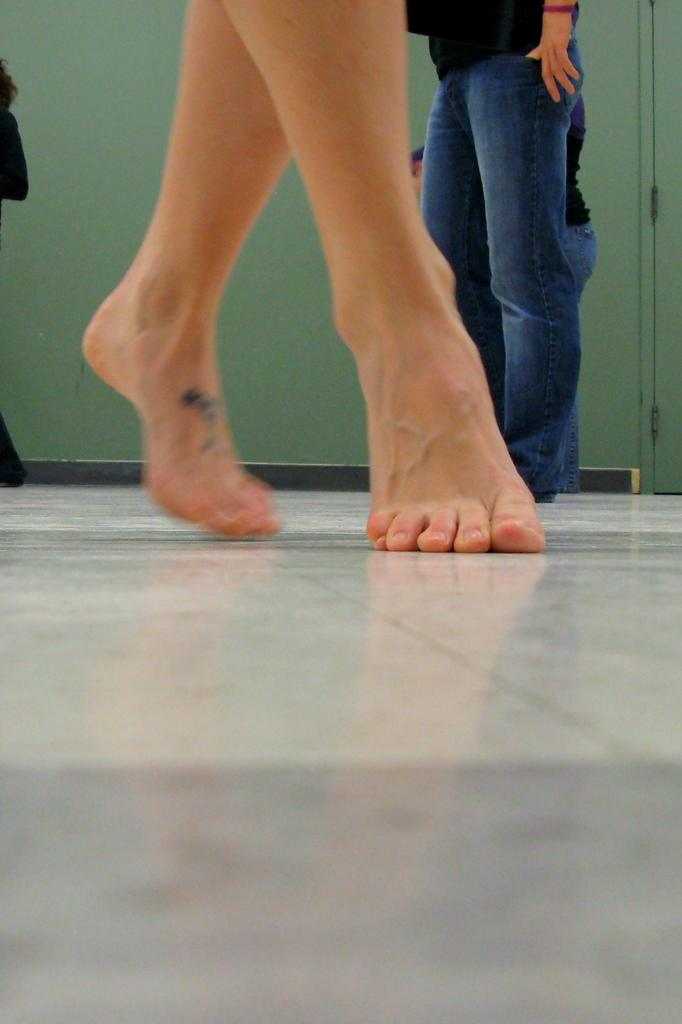What is the person in the foreground of the image doing? The person is standing on their toes in the image. Can you describe the position of the second person in the image? The second person is standing on the floor in the background of the image. What can be seen in the background of the image? There is a wall visible in the background of the image. What type of tree can be seen growing on the person's head in the image? There is no tree present in the image, and no tree is growing on anyone's head. 